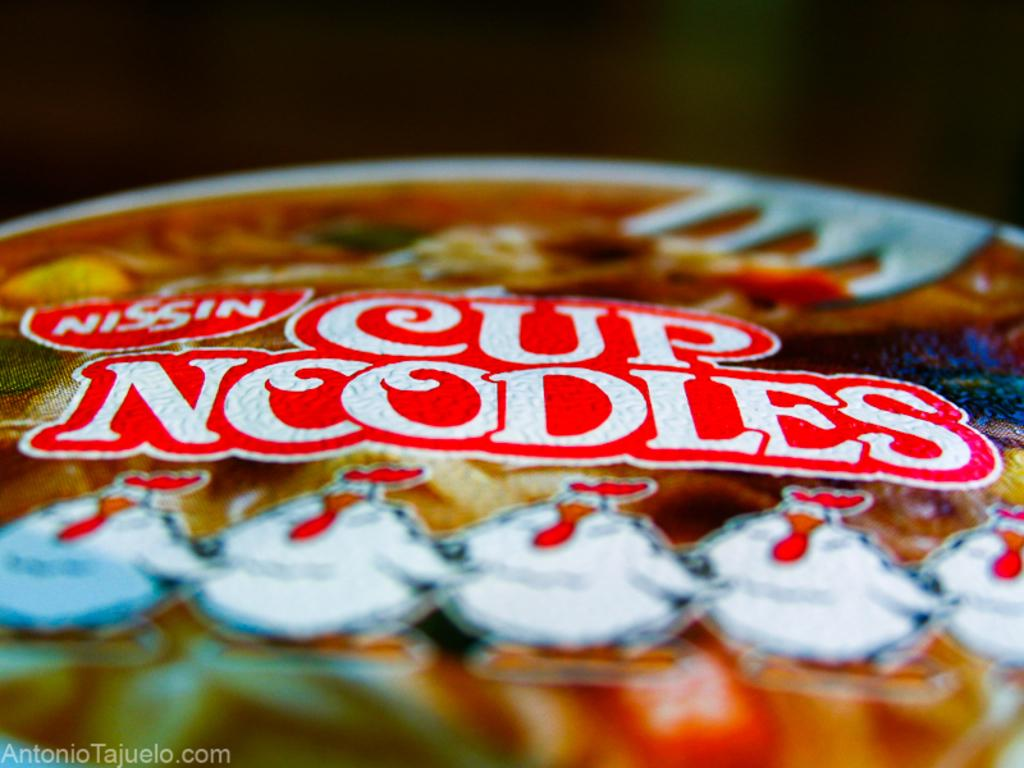What is in the cup that is visible in the image? There is a cup of noodles in the image. What type of pies can be seen in the image? There are no pies present in the image; it features a cup of noodles. What button is being pressed in the image? There is no button being pressed in the image; it only shows a cup of noodles. 